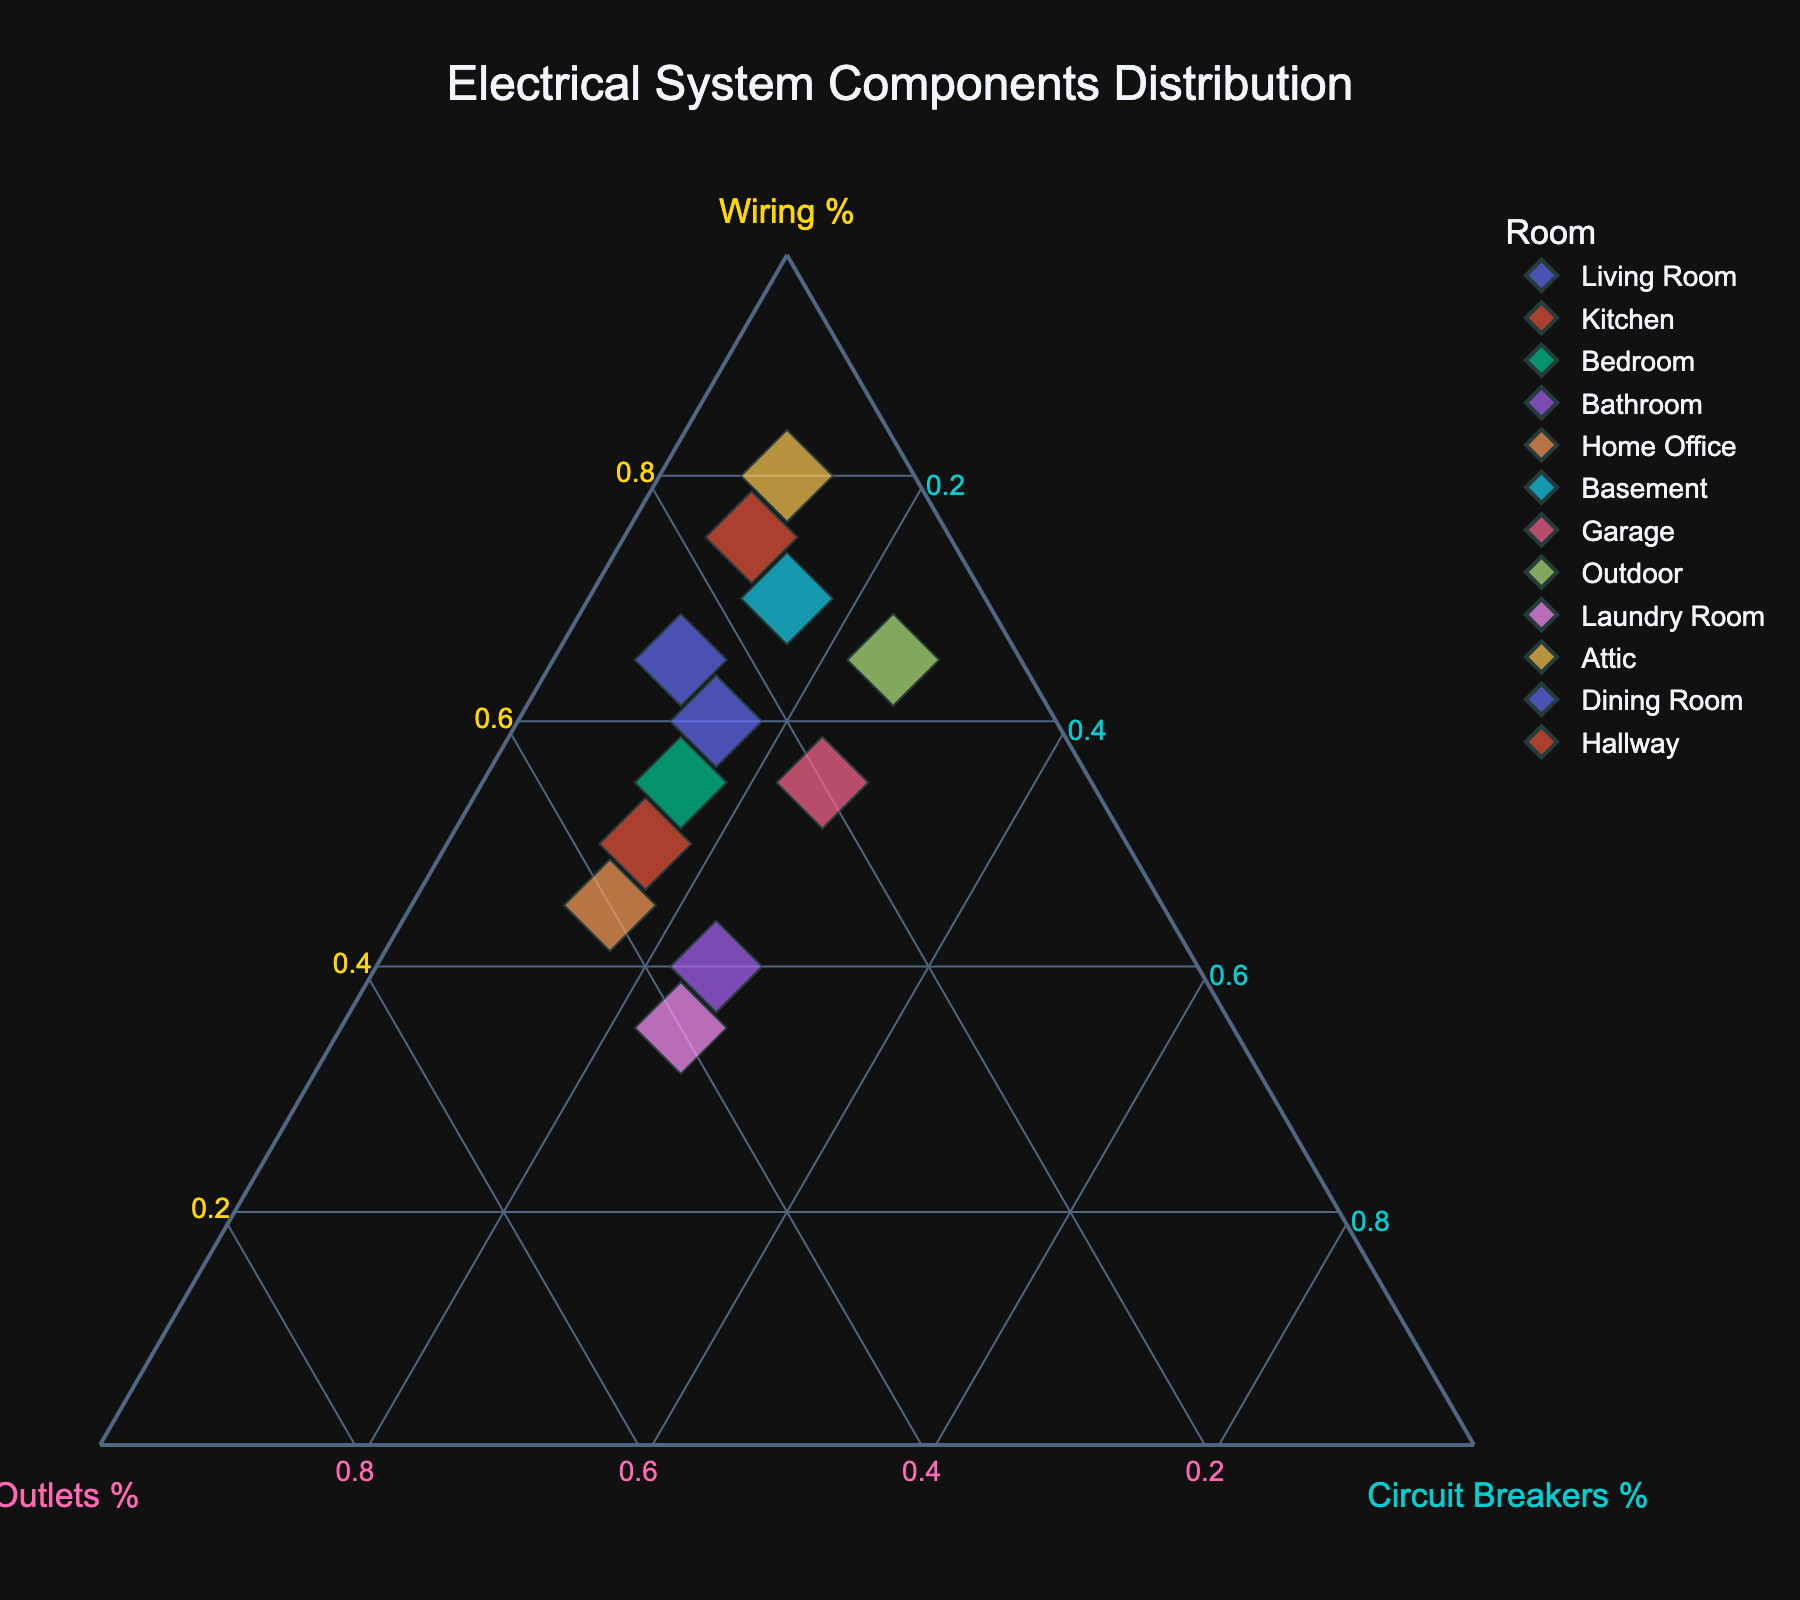What is the title of the ternary plot? The title of a plot is typically located at the top center and provides a summary of the plot's content. By looking at the figure, you should see a descriptive title indicating what the plot is about.
Answer: Electrical System Components Distribution Which component has the highest percentage of wiring? To determine the highest percentage of wiring, you need to look at the axis labeled "Wiring %" and find the point that is furthest along this axis. In this case, 80% is the highest, and it corresponds to the Attic.
Answer: Attic Which room has the smallest proportion of outlets? Check the axis labeled "Outlets %" and identify the point closest to the origin of this axis, meaning it has the lowest percentage of outlets. The points at 10% for outlets correspond to Attic and Outdoor.
Answer: Attic and Outdoor How many data points represent rooms with at least 15% for each component? Look at the plot and ensure each selected data point has ≥15% on the "Wiring %", "Outlets %", and "Circuit Breakers %" axes. Points that meet this criteria are Living Room, Kitchen, Bedroom, Bathroom, Home Office, Garage, Laundry Room.
Answer: 7 Which component has a higher percentage of wiring than outlets but also a higher percentage of outlets than circuit breakers? To answer this, you need to find points where the wiring percentage is greater than the outlets percentage (W > O) and the outlets percentage is greater than the circuit breakers percentage (O > C). Both conditions must be true. Rooms meeting this are Living Room, Kitchen, Bedroom.
Answer: Living Room, Kitchen, Bedroom Is there any room where the percentage of circuit breakers is higher than the outlets? Find data points where the values on the "Circuit Breakers %" axis are higher than the values on the "Outlets %" axis. For this plot, those points are Garage, Outdoor, and Laundry Room.
Answer: Garage, Outdoor, Laundry Room Which room has the highest total number of components (wiring, outlets, and circuit breakers combined)? Look for the data point represented by the largest marker, as the marker size is proportional to the total number of components. The room with the largest marker is the Attic.
Answer: Attic Which room has a similar component distribution as the Bathroom but a different total number? Find points close to the Bathroom in terms of proportions on the ternary plot but have different marker sizes. The Garage has a similar wiring, outlets, and circuit breakers distribution but a different total number.
Answer: Garage 